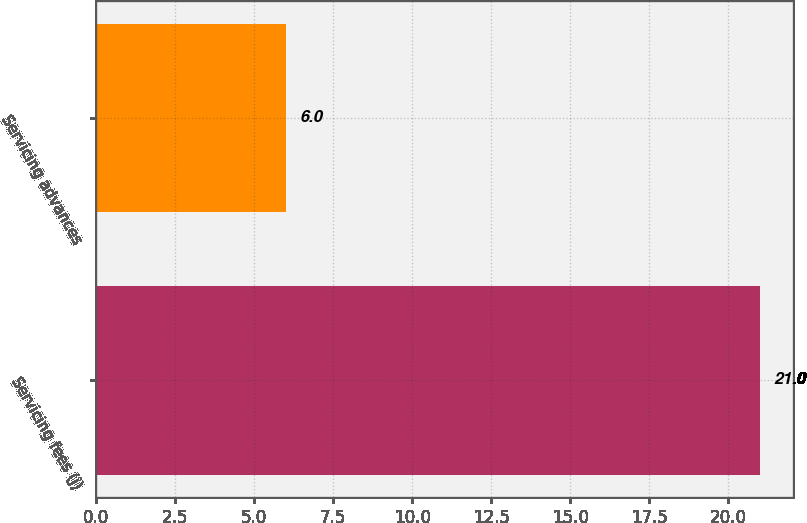<chart> <loc_0><loc_0><loc_500><loc_500><bar_chart><fcel>Servicing fees (j)<fcel>Servicing advances<nl><fcel>21<fcel>6<nl></chart> 